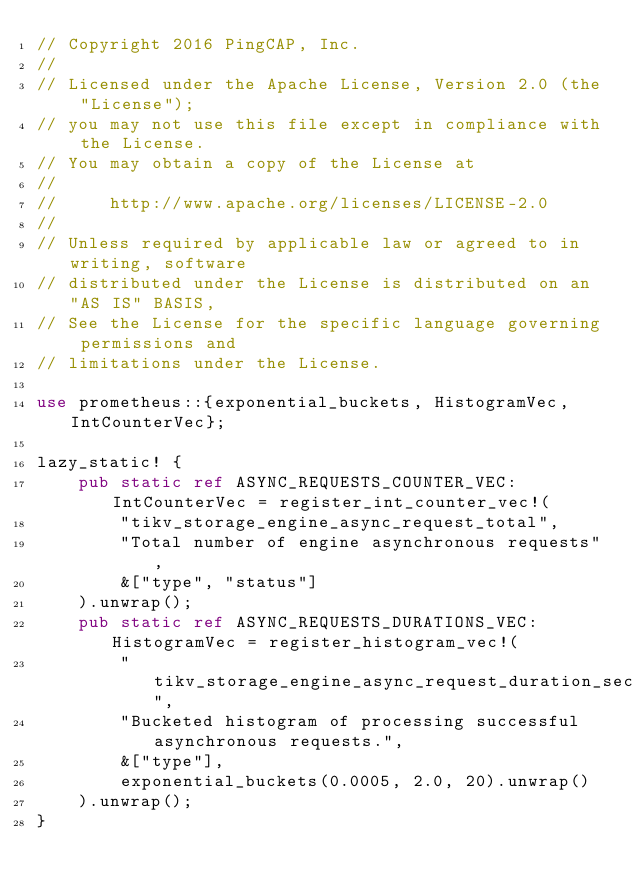Convert code to text. <code><loc_0><loc_0><loc_500><loc_500><_Rust_>// Copyright 2016 PingCAP, Inc.
//
// Licensed under the Apache License, Version 2.0 (the "License");
// you may not use this file except in compliance with the License.
// You may obtain a copy of the License at
//
//     http://www.apache.org/licenses/LICENSE-2.0
//
// Unless required by applicable law or agreed to in writing, software
// distributed under the License is distributed on an "AS IS" BASIS,
// See the License for the specific language governing permissions and
// limitations under the License.

use prometheus::{exponential_buckets, HistogramVec, IntCounterVec};

lazy_static! {
    pub static ref ASYNC_REQUESTS_COUNTER_VEC: IntCounterVec = register_int_counter_vec!(
        "tikv_storage_engine_async_request_total",
        "Total number of engine asynchronous requests",
        &["type", "status"]
    ).unwrap();
    pub static ref ASYNC_REQUESTS_DURATIONS_VEC: HistogramVec = register_histogram_vec!(
        "tikv_storage_engine_async_request_duration_seconds",
        "Bucketed histogram of processing successful asynchronous requests.",
        &["type"],
        exponential_buckets(0.0005, 2.0, 20).unwrap()
    ).unwrap();
}
</code> 